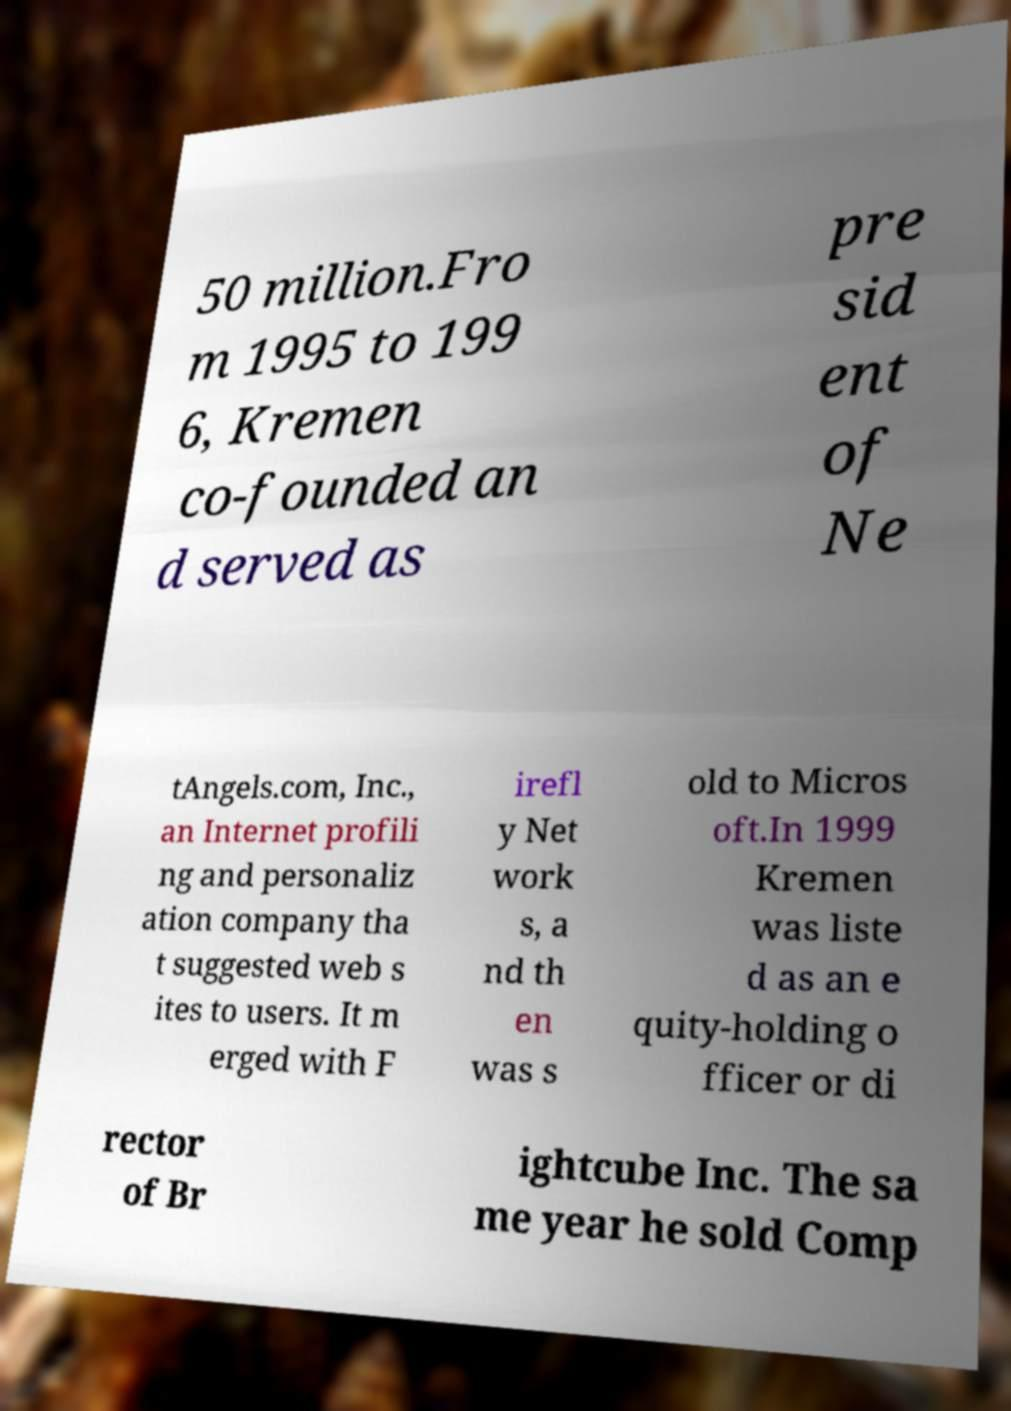Could you extract and type out the text from this image? 50 million.Fro m 1995 to 199 6, Kremen co-founded an d served as pre sid ent of Ne tAngels.com, Inc., an Internet profili ng and personaliz ation company tha t suggested web s ites to users. It m erged with F irefl y Net work s, a nd th en was s old to Micros oft.In 1999 Kremen was liste d as an e quity-holding o fficer or di rector of Br ightcube Inc. The sa me year he sold Comp 